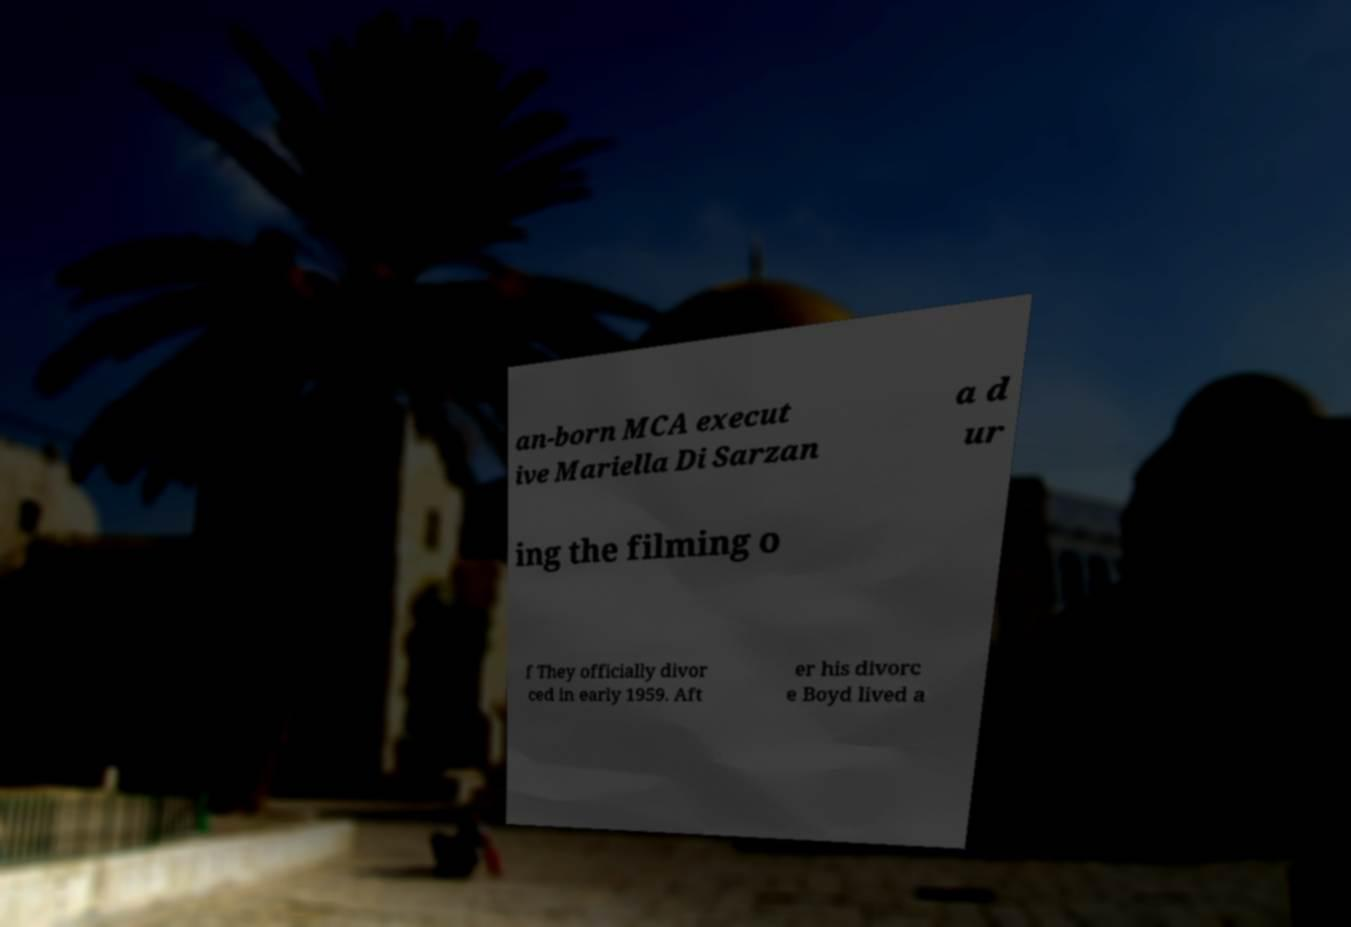For documentation purposes, I need the text within this image transcribed. Could you provide that? an-born MCA execut ive Mariella Di Sarzan a d ur ing the filming o f They officially divor ced in early 1959. Aft er his divorc e Boyd lived a 